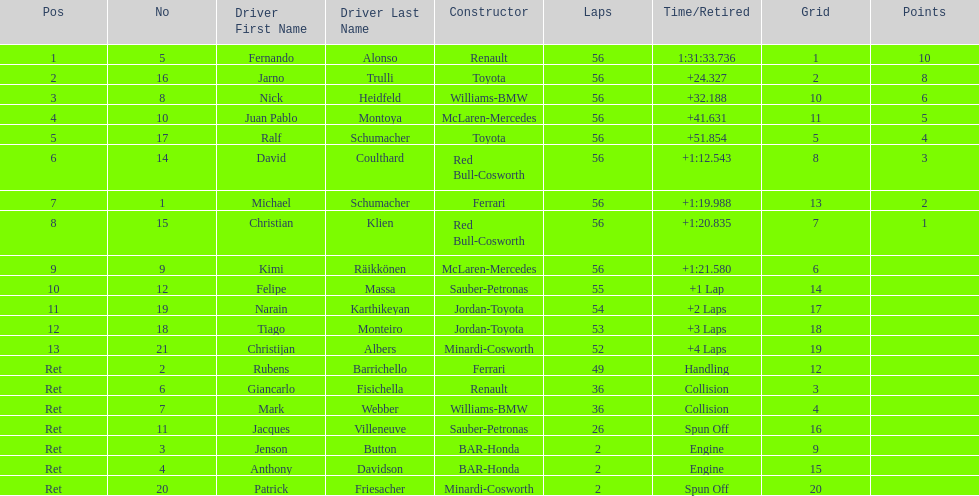How long did it take for heidfeld to finish? 1:31:65.924. 